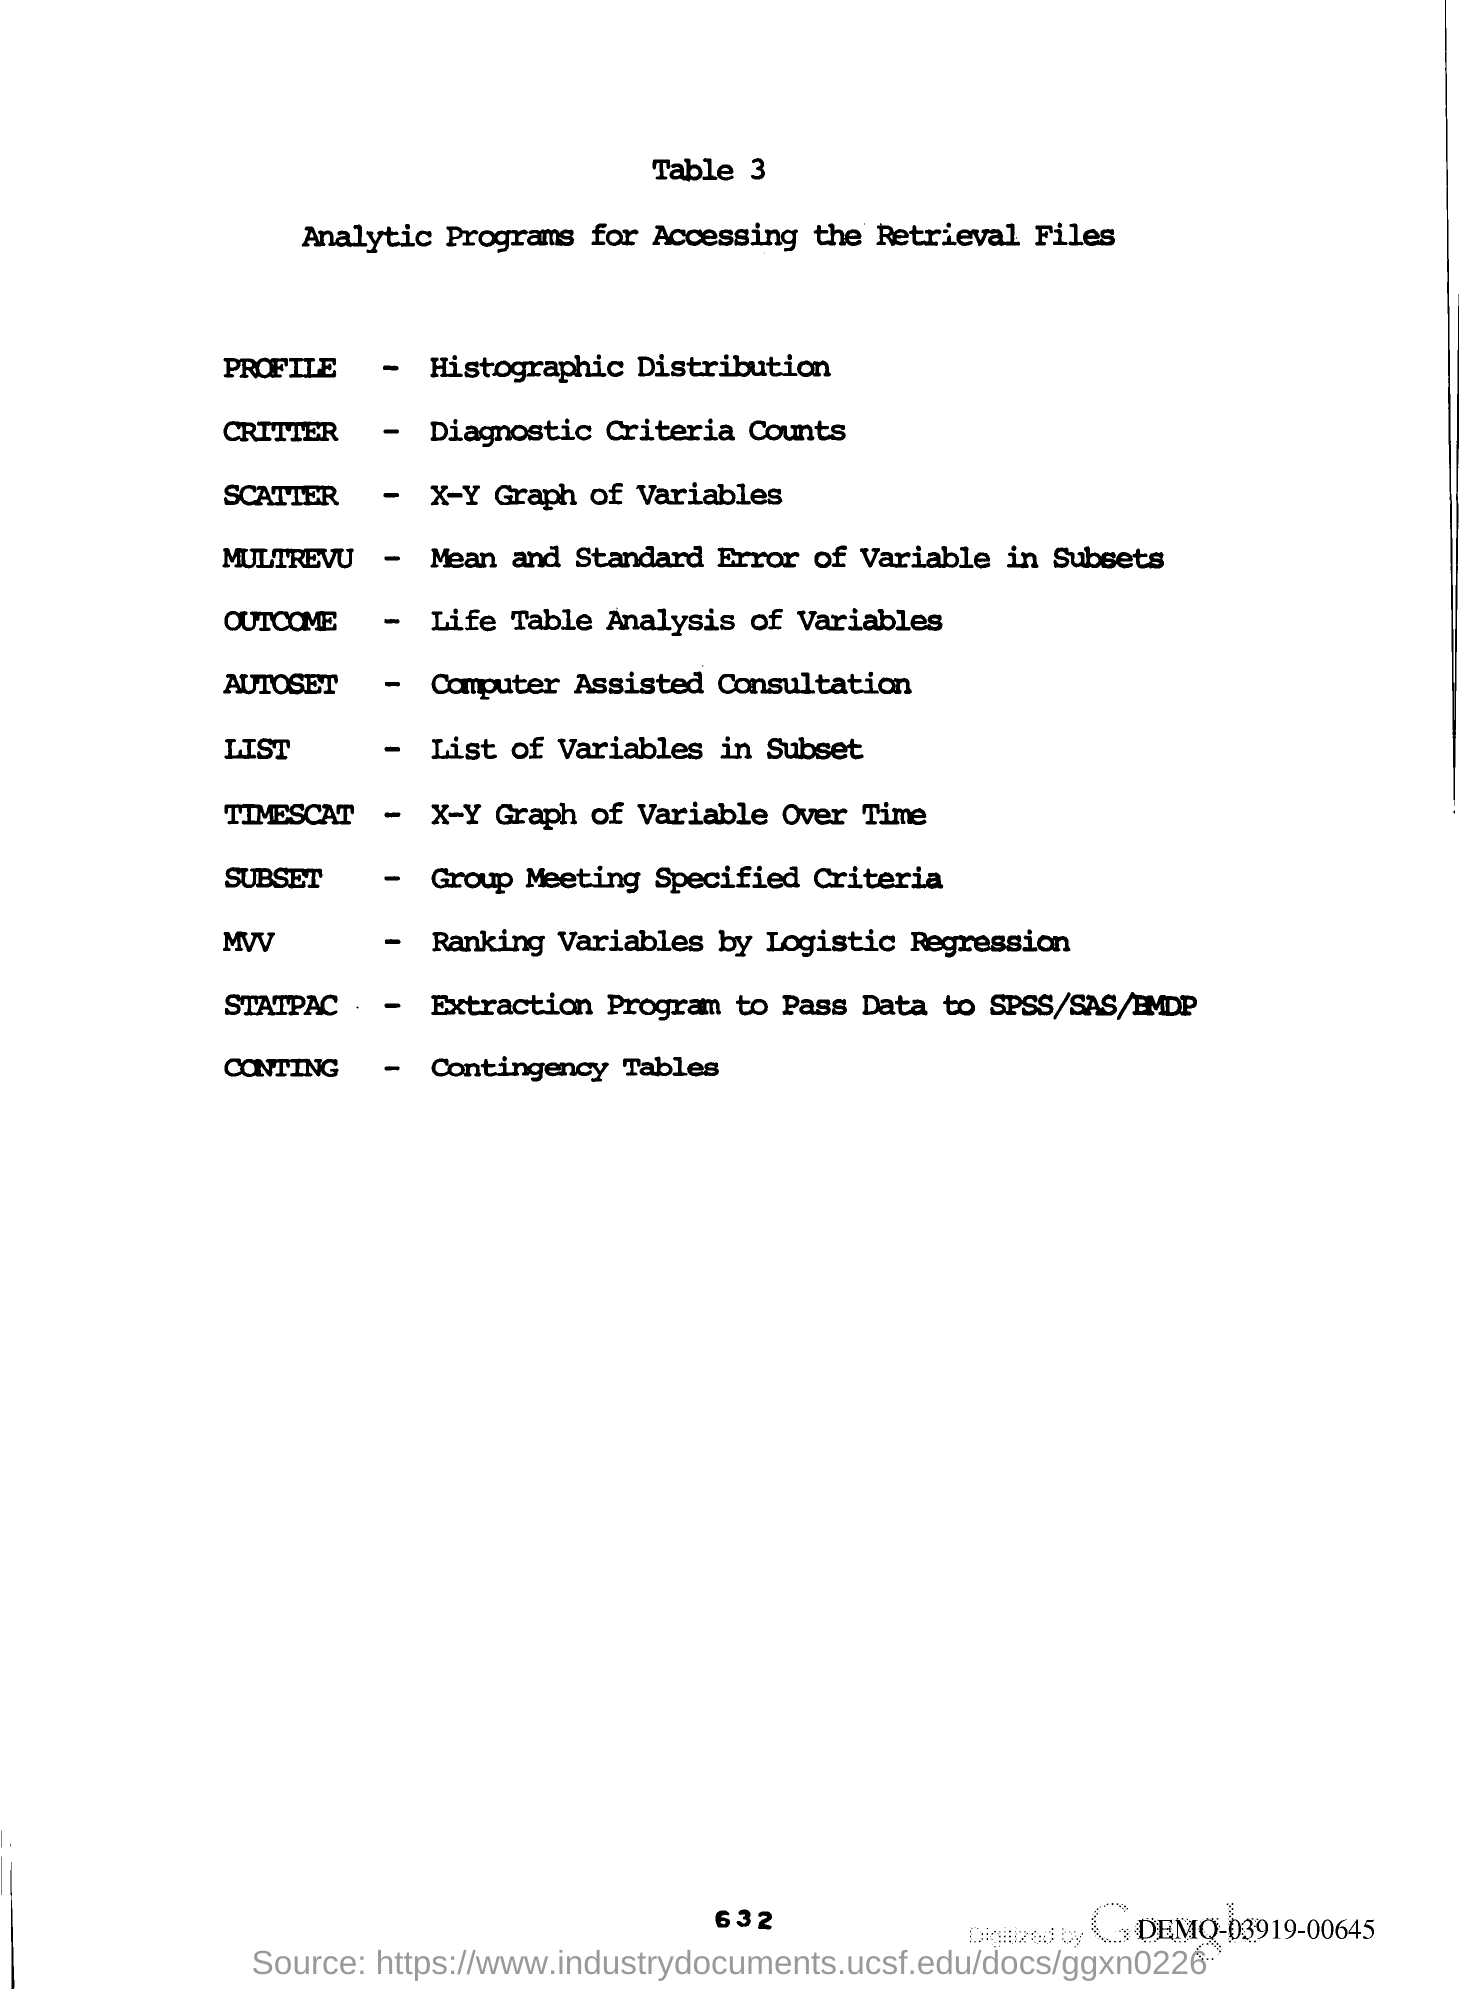Indicate a few pertinent items in this graphic. The page number mentioned in this document is 632. The title of Table 3 in the document 'Analytic Programs for Accessing the Retrieval Files' is 'Analytic Programs for Accessing the Retrieval Files'. 